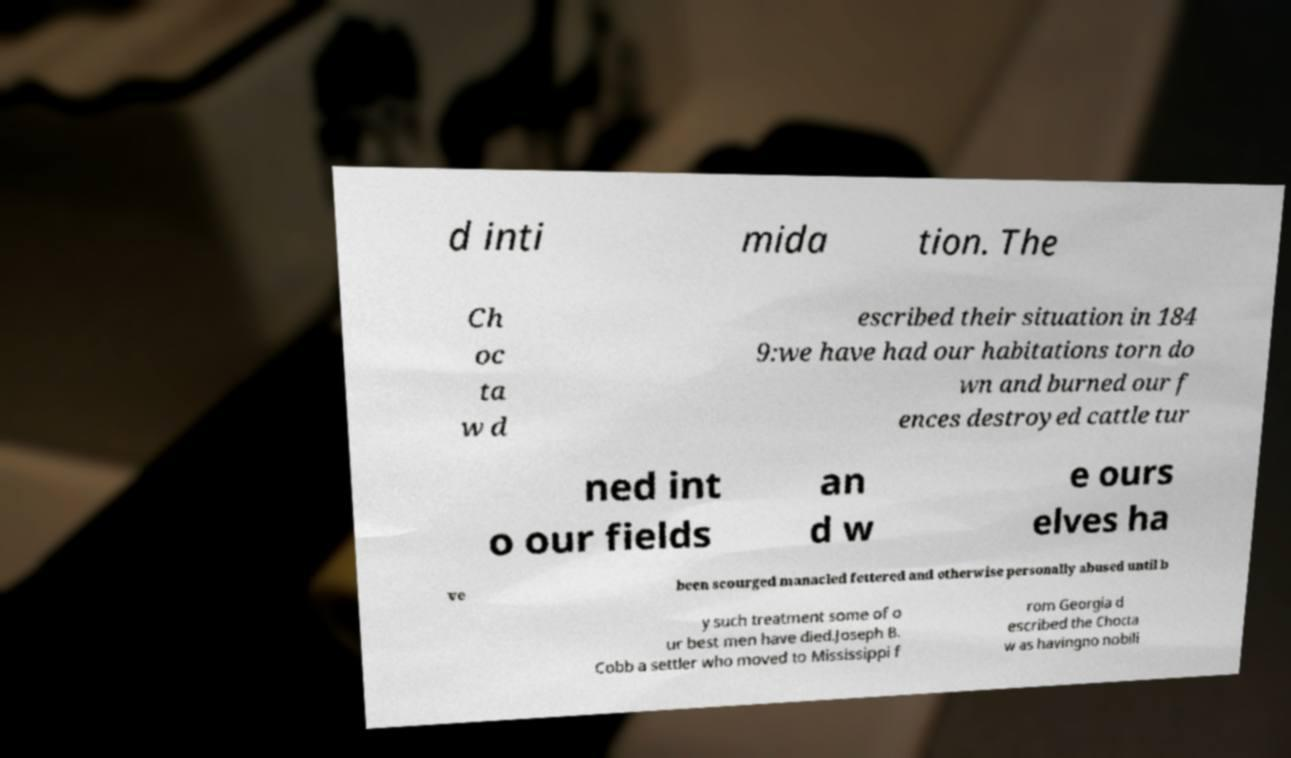I need the written content from this picture converted into text. Can you do that? d inti mida tion. The Ch oc ta w d escribed their situation in 184 9:we have had our habitations torn do wn and burned our f ences destroyed cattle tur ned int o our fields an d w e ours elves ha ve been scourged manacled fettered and otherwise personally abused until b y such treatment some of o ur best men have died.Joseph B. Cobb a settler who moved to Mississippi f rom Georgia d escribed the Chocta w as havingno nobili 